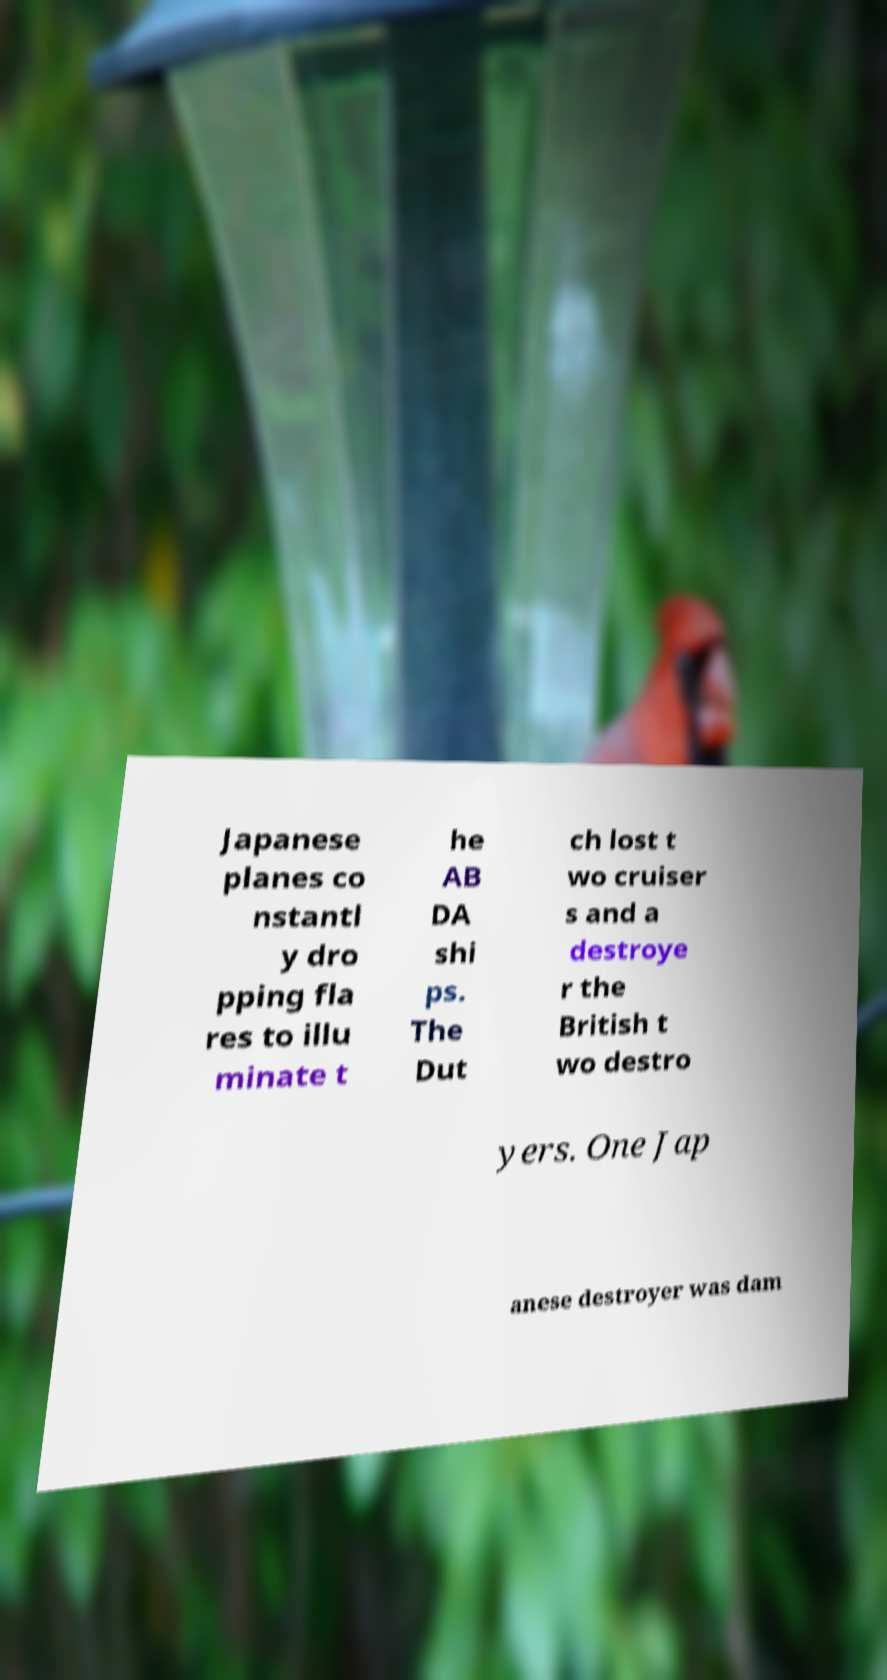Can you read and provide the text displayed in the image?This photo seems to have some interesting text. Can you extract and type it out for me? Japanese planes co nstantl y dro pping fla res to illu minate t he AB DA shi ps. The Dut ch lost t wo cruiser s and a destroye r the British t wo destro yers. One Jap anese destroyer was dam 